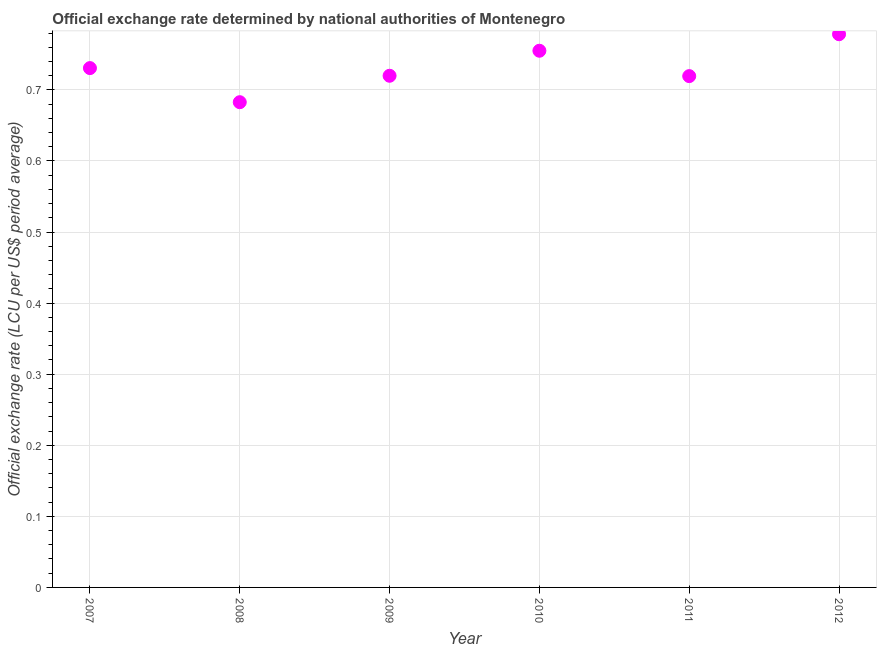What is the official exchange rate in 2010?
Your answer should be very brief. 0.76. Across all years, what is the maximum official exchange rate?
Offer a very short reply. 0.78. Across all years, what is the minimum official exchange rate?
Offer a terse response. 0.68. In which year was the official exchange rate maximum?
Offer a very short reply. 2012. In which year was the official exchange rate minimum?
Provide a succinct answer. 2008. What is the sum of the official exchange rate?
Offer a terse response. 4.39. What is the difference between the official exchange rate in 2007 and 2011?
Make the answer very short. 0.01. What is the average official exchange rate per year?
Your answer should be very brief. 0.73. What is the median official exchange rate?
Ensure brevity in your answer.  0.73. What is the ratio of the official exchange rate in 2011 to that in 2012?
Offer a very short reply. 0.92. What is the difference between the highest and the second highest official exchange rate?
Your response must be concise. 0.02. Is the sum of the official exchange rate in 2007 and 2009 greater than the maximum official exchange rate across all years?
Ensure brevity in your answer.  Yes. What is the difference between the highest and the lowest official exchange rate?
Offer a very short reply. 0.1. Does the official exchange rate monotonically increase over the years?
Give a very brief answer. No. Are the values on the major ticks of Y-axis written in scientific E-notation?
Provide a short and direct response. No. What is the title of the graph?
Provide a short and direct response. Official exchange rate determined by national authorities of Montenegro. What is the label or title of the Y-axis?
Your answer should be compact. Official exchange rate (LCU per US$ period average). What is the Official exchange rate (LCU per US$ period average) in 2007?
Offer a terse response. 0.73. What is the Official exchange rate (LCU per US$ period average) in 2008?
Provide a short and direct response. 0.68. What is the Official exchange rate (LCU per US$ period average) in 2009?
Your response must be concise. 0.72. What is the Official exchange rate (LCU per US$ period average) in 2010?
Give a very brief answer. 0.76. What is the Official exchange rate (LCU per US$ period average) in 2011?
Offer a terse response. 0.72. What is the Official exchange rate (LCU per US$ period average) in 2012?
Your response must be concise. 0.78. What is the difference between the Official exchange rate (LCU per US$ period average) in 2007 and 2008?
Give a very brief answer. 0.05. What is the difference between the Official exchange rate (LCU per US$ period average) in 2007 and 2009?
Provide a short and direct response. 0.01. What is the difference between the Official exchange rate (LCU per US$ period average) in 2007 and 2010?
Your answer should be compact. -0.02. What is the difference between the Official exchange rate (LCU per US$ period average) in 2007 and 2011?
Your response must be concise. 0.01. What is the difference between the Official exchange rate (LCU per US$ period average) in 2007 and 2012?
Make the answer very short. -0.05. What is the difference between the Official exchange rate (LCU per US$ period average) in 2008 and 2009?
Keep it short and to the point. -0.04. What is the difference between the Official exchange rate (LCU per US$ period average) in 2008 and 2010?
Give a very brief answer. -0.07. What is the difference between the Official exchange rate (LCU per US$ period average) in 2008 and 2011?
Keep it short and to the point. -0.04. What is the difference between the Official exchange rate (LCU per US$ period average) in 2008 and 2012?
Offer a terse response. -0.1. What is the difference between the Official exchange rate (LCU per US$ period average) in 2009 and 2010?
Your response must be concise. -0.04. What is the difference between the Official exchange rate (LCU per US$ period average) in 2009 and 2011?
Give a very brief answer. 0. What is the difference between the Official exchange rate (LCU per US$ period average) in 2009 and 2012?
Your answer should be compact. -0.06. What is the difference between the Official exchange rate (LCU per US$ period average) in 2010 and 2011?
Your answer should be compact. 0.04. What is the difference between the Official exchange rate (LCU per US$ period average) in 2010 and 2012?
Ensure brevity in your answer.  -0.02. What is the difference between the Official exchange rate (LCU per US$ period average) in 2011 and 2012?
Make the answer very short. -0.06. What is the ratio of the Official exchange rate (LCU per US$ period average) in 2007 to that in 2008?
Your answer should be very brief. 1.07. What is the ratio of the Official exchange rate (LCU per US$ period average) in 2007 to that in 2009?
Provide a succinct answer. 1.01. What is the ratio of the Official exchange rate (LCU per US$ period average) in 2007 to that in 2010?
Your answer should be compact. 0.97. What is the ratio of the Official exchange rate (LCU per US$ period average) in 2007 to that in 2012?
Your answer should be very brief. 0.94. What is the ratio of the Official exchange rate (LCU per US$ period average) in 2008 to that in 2009?
Ensure brevity in your answer.  0.95. What is the ratio of the Official exchange rate (LCU per US$ period average) in 2008 to that in 2010?
Give a very brief answer. 0.9. What is the ratio of the Official exchange rate (LCU per US$ period average) in 2008 to that in 2011?
Ensure brevity in your answer.  0.95. What is the ratio of the Official exchange rate (LCU per US$ period average) in 2008 to that in 2012?
Ensure brevity in your answer.  0.88. What is the ratio of the Official exchange rate (LCU per US$ period average) in 2009 to that in 2010?
Make the answer very short. 0.95. What is the ratio of the Official exchange rate (LCU per US$ period average) in 2009 to that in 2011?
Your response must be concise. 1. What is the ratio of the Official exchange rate (LCU per US$ period average) in 2009 to that in 2012?
Ensure brevity in your answer.  0.93. What is the ratio of the Official exchange rate (LCU per US$ period average) in 2010 to that in 2011?
Provide a succinct answer. 1.05. What is the ratio of the Official exchange rate (LCU per US$ period average) in 2010 to that in 2012?
Offer a terse response. 0.97. What is the ratio of the Official exchange rate (LCU per US$ period average) in 2011 to that in 2012?
Ensure brevity in your answer.  0.92. 